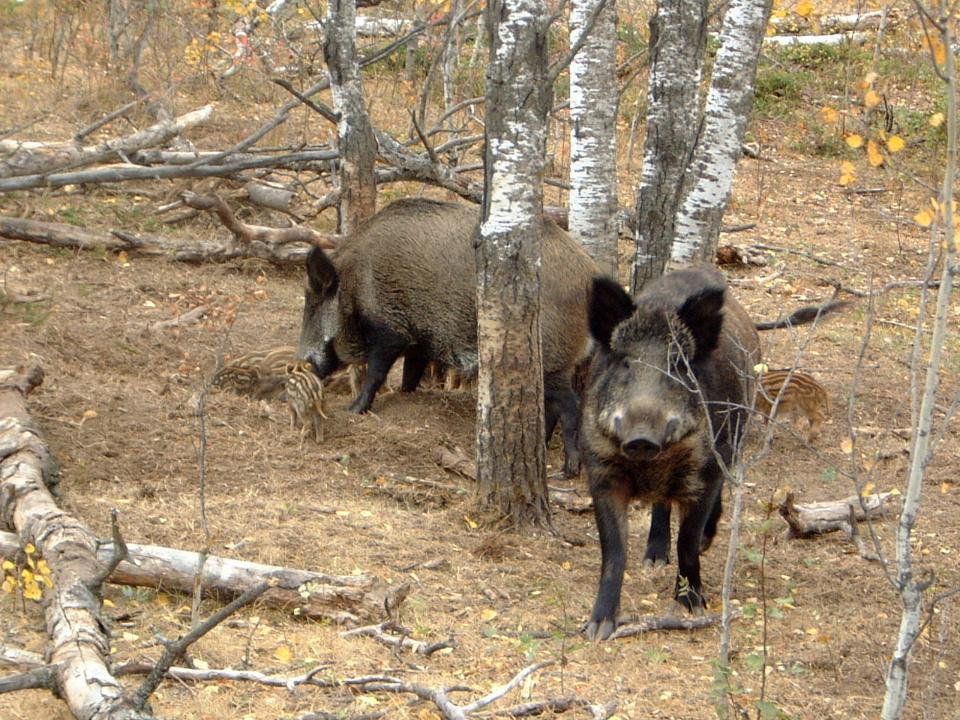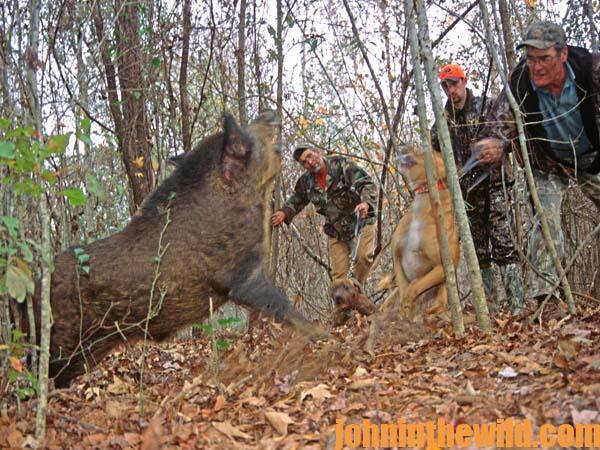The first image is the image on the left, the second image is the image on the right. For the images displayed, is the sentence "A man is holding a gun horizontally." factually correct? Answer yes or no. No. The first image is the image on the left, the second image is the image on the right. Examine the images to the left and right. Is the description "One of the images has at least one person posing over a dead animal on snowy ground." accurate? Answer yes or no. No. 